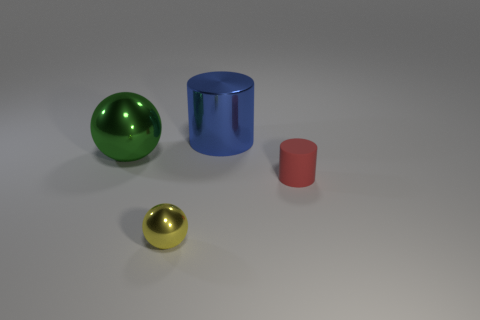Add 3 large cyan metal cylinders. How many objects exist? 7 Add 4 tiny metallic objects. How many tiny metallic objects exist? 5 Subtract 0 brown cubes. How many objects are left? 4 Subtract all large blue metallic objects. Subtract all small cyan metallic objects. How many objects are left? 3 Add 1 tiny metallic objects. How many tiny metallic objects are left? 2 